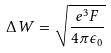<formula> <loc_0><loc_0><loc_500><loc_500>\Delta W = \sqrt { \frac { e ^ { 3 } F } { 4 \pi \epsilon _ { 0 } } }</formula> 